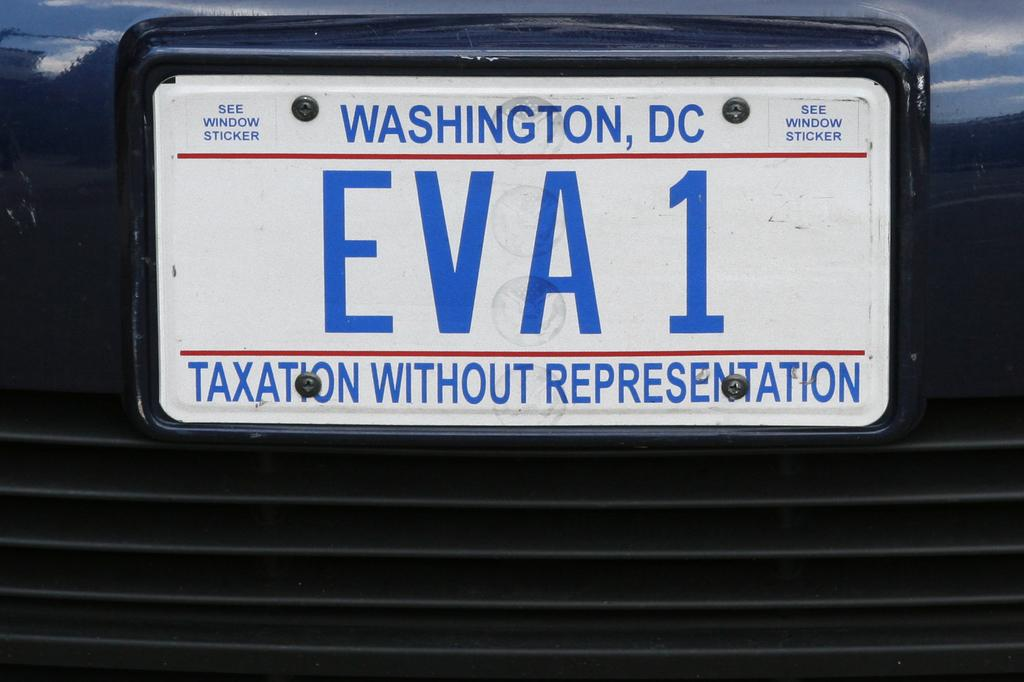What can be seen on the vehicle in the image? There is a vehicle number plate in the image. What is written or displayed on the vehicle number plate? There is text visible on the vehicle number plate. Can you hear the whistle coming from the vehicle in the image? There is no whistle present in the image, as it only features a vehicle number plate. What type of throat condition does the driver of the vehicle have in the image? There is no information about the driver or their throat condition in the image. 